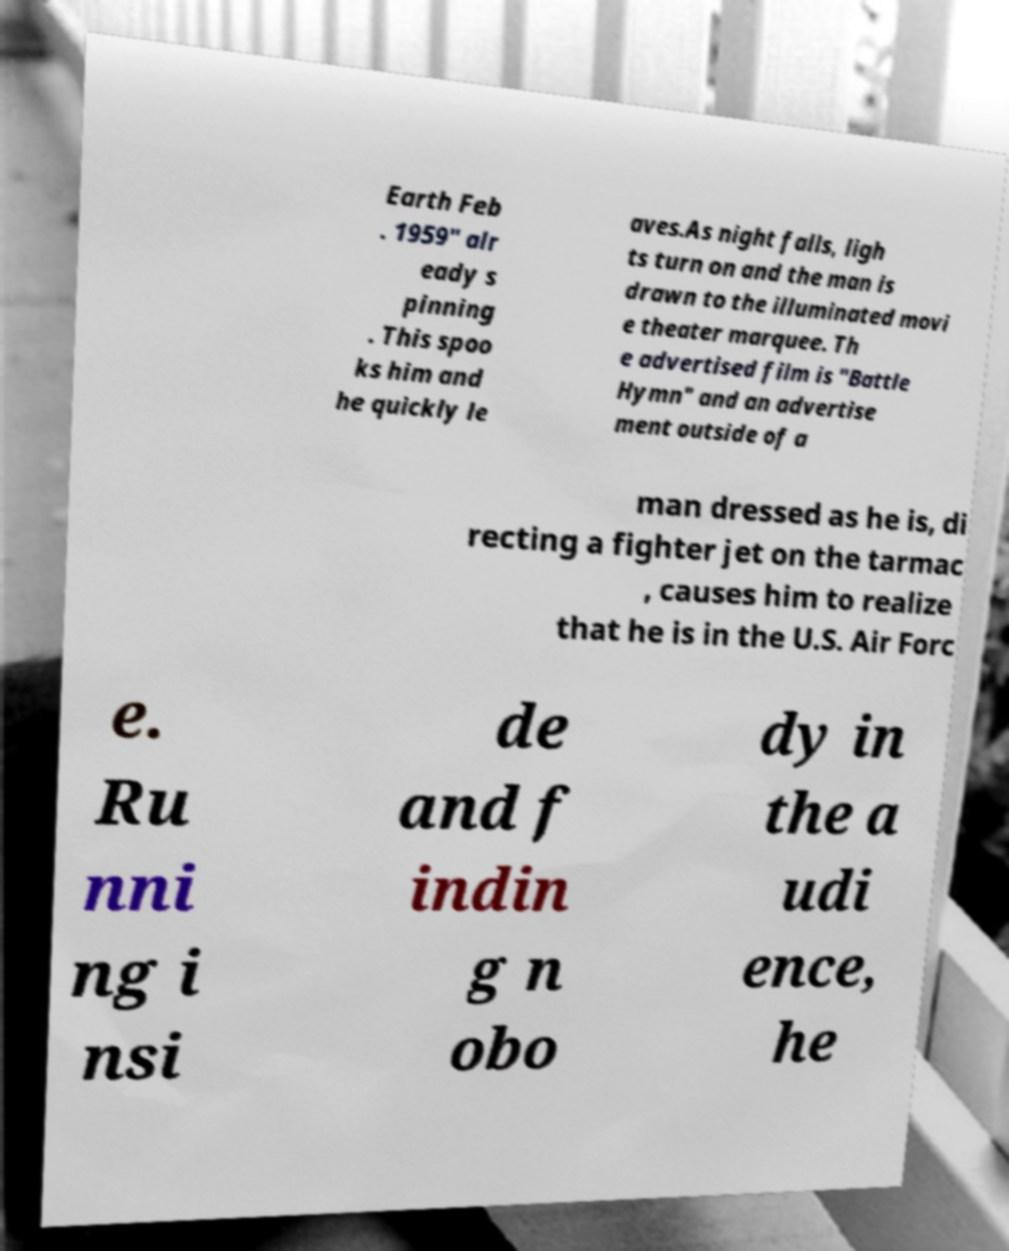There's text embedded in this image that I need extracted. Can you transcribe it verbatim? Earth Feb . 1959" alr eady s pinning . This spoo ks him and he quickly le aves.As night falls, ligh ts turn on and the man is drawn to the illuminated movi e theater marquee. Th e advertised film is "Battle Hymn" and an advertise ment outside of a man dressed as he is, di recting a fighter jet on the tarmac , causes him to realize that he is in the U.S. Air Forc e. Ru nni ng i nsi de and f indin g n obo dy in the a udi ence, he 